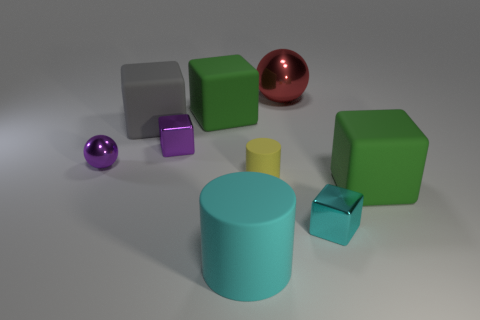What size is the purple metal thing right of the small purple ball?
Give a very brief answer. Small. Are there more purple metal things that are behind the large gray object than large red metal cylinders?
Ensure brevity in your answer.  No. The large gray thing is what shape?
Provide a short and direct response. Cube. There is a big cube that is in front of the tiny rubber object; does it have the same color as the large cube that is behind the large gray cube?
Provide a short and direct response. Yes. Does the tiny yellow object have the same shape as the big cyan thing?
Provide a short and direct response. Yes. Is the big thing in front of the cyan cube made of the same material as the big gray thing?
Offer a very short reply. Yes. What is the shape of the matte object that is both to the left of the tiny matte object and in front of the gray rubber block?
Your answer should be very brief. Cylinder. There is a green rubber block that is behind the small purple metallic sphere; is there a big thing that is on the left side of it?
Give a very brief answer. Yes. How many other objects are there of the same material as the red sphere?
Offer a terse response. 3. There is a tiny metallic object right of the big red shiny ball; is it the same shape as the large green object that is on the left side of the big matte cylinder?
Your response must be concise. Yes. 